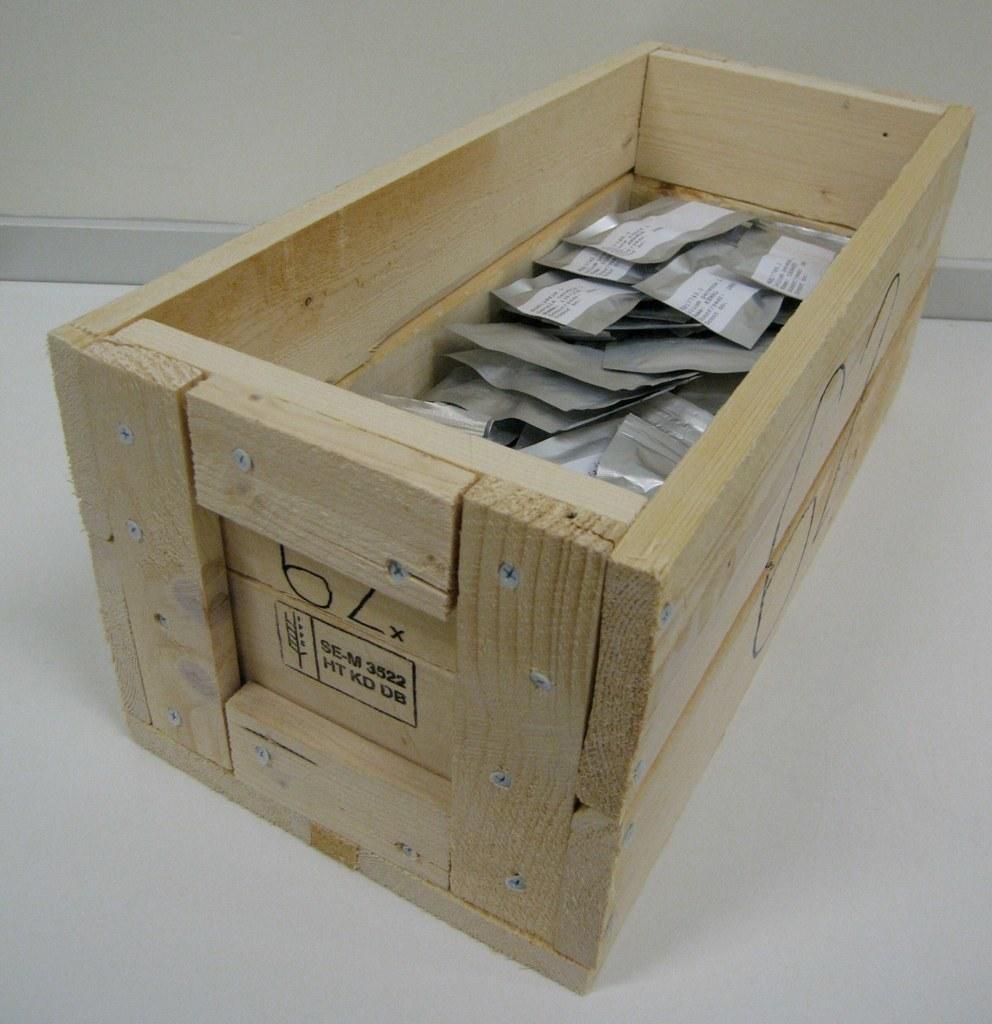Describe this image in one or two sentences. In this picture we can see a wooden box with some objects in it and this wooden box is on the ground and we can see a wall in the background. 